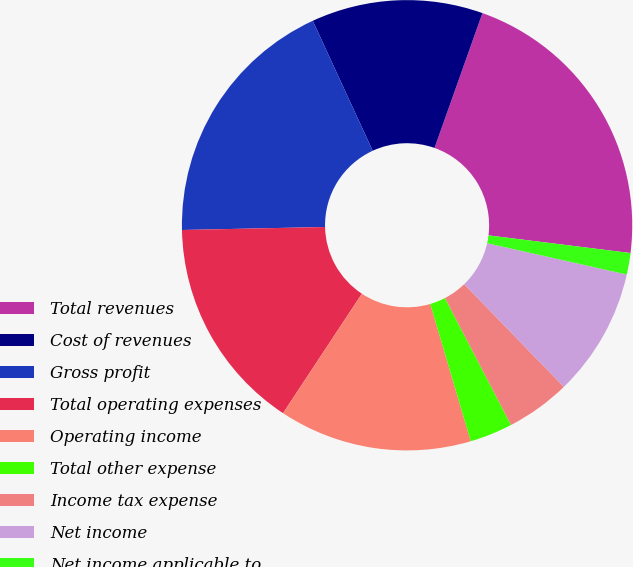Convert chart to OTSL. <chart><loc_0><loc_0><loc_500><loc_500><pie_chart><fcel>Total revenues<fcel>Cost of revenues<fcel>Gross profit<fcel>Total operating expenses<fcel>Operating income<fcel>Total other expense<fcel>Income tax expense<fcel>Net income<fcel>Net income applicable to<nl><fcel>21.54%<fcel>12.31%<fcel>18.46%<fcel>15.38%<fcel>13.85%<fcel>3.08%<fcel>4.62%<fcel>9.23%<fcel>1.54%<nl></chart> 